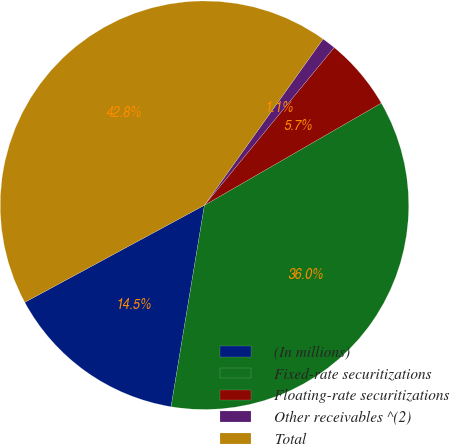<chart> <loc_0><loc_0><loc_500><loc_500><pie_chart><fcel>(In millions)<fcel>Fixed-rate securitizations<fcel>Floating-rate securitizations<fcel>Other receivables ^(2)<fcel>Total<nl><fcel>14.5%<fcel>35.95%<fcel>5.71%<fcel>1.09%<fcel>42.75%<nl></chart> 